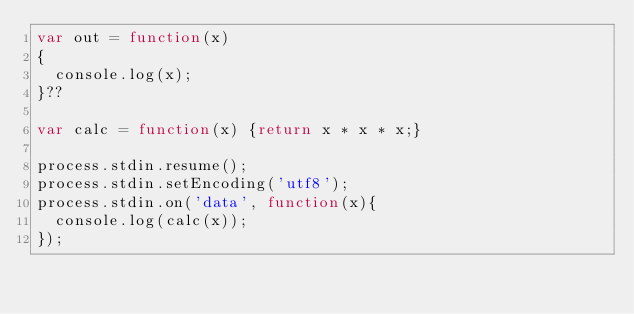<code> <loc_0><loc_0><loc_500><loc_500><_JavaScript_>var out = function(x)
{
  console.log(x);
}??

var calc = function(x) {return x * x * x;}

process.stdin.resume();
process.stdin.setEncoding('utf8');
process.stdin.on('data', function(x){
  console.log(calc(x));
});</code> 